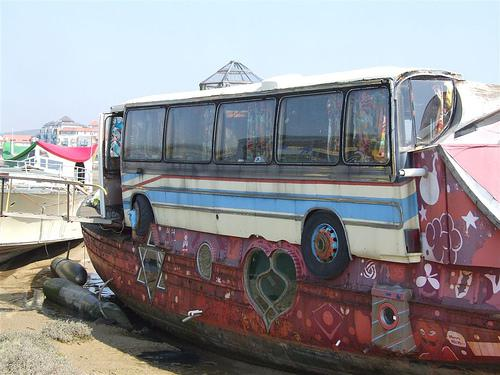Question: how many boats are there?
Choices:
A. Two.
B. Three.
C. One.
D. Zero.
Answer with the letter. Answer: C Question: how is the weather?
Choices:
A. Clear.
B. Sunny.
C. Rainy.
D. Cloudy.
Answer with the letter. Answer: A 